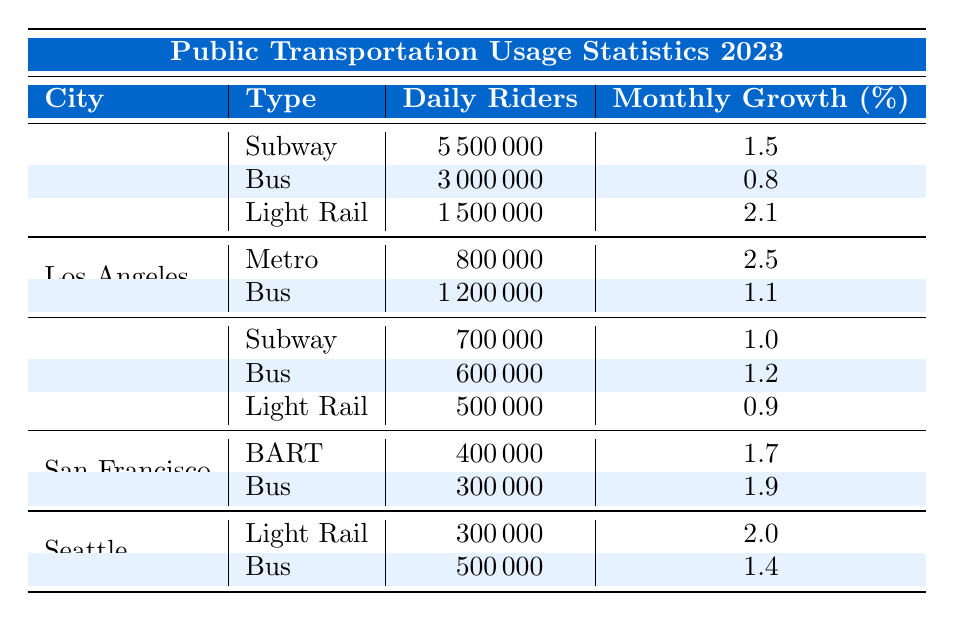What city has the highest daily riders for public transportation? Referring to the table, New York has the highest daily riders with 5,500,000 subway riders.
Answer: New York Which type of public transportation in Chicago has the lowest daily ridership? In Chicago, the Light Rail has the lowest daily ridership with 500,000 riders compared to subway and bus.
Answer: Light Rail What is the monthly growth percentage for the Metro in Los Angeles? The table shows that the Metro in Los Angeles has a monthly growth percentage of 2.5%.
Answer: 2.5 What is the total daily ridership of public transportation in San Francisco? The total daily ridership in San Francisco is 400,000 (BART) + 300,000 (Bus) = 700,000.
Answer: 700,000 Is the monthly growth rate for buses in Seattle higher than in Chicago? In Seattle, the monthly growth rate for buses is 1.4%, while in Chicago, it is 1.2%. Thus, it is higher in Seattle.
Answer: Yes Which city has a higher daily ridership for Light Rail, New York or Seattle? New York has 1,500,000 daily riders for Light Rail, while Seattle has only 300,000. Therefore, New York has a higher ridership.
Answer: New York What is the average monthly growth percentage for all cities' bus services? The monthly growth for buses is 0.8% (NY) + 1.1% (LA) + 1.2% (Chicago) + 1.9% (San Francisco) + 1.4% (Seattle) = 6.4%. The average is 6.4% / 5 = 1.28%.
Answer: 1.28% How many more daily riders does the Subway in New York have compared to the Bus in Chicago? The Subway in New York has 5,500,000 riders and the Bus in Chicago has 600,000 riders. The difference is 5,500,000 - 600,000 = 4,900,000.
Answer: 4,900,000 Which city has the lowest total public transportation ridership, based on the data provided? By adding all daily riders from each city, San Francisco has the lowest total with 700,000.
Answer: San Francisco Is there a city where the Light Rail has a higher daily ridership than the bus? In Seattle, the daily ridership for the Bus is 500,000 and for Light Rail, it’s 300,000. So, no city has Light Rail with higher ridership than the bus.
Answer: No 